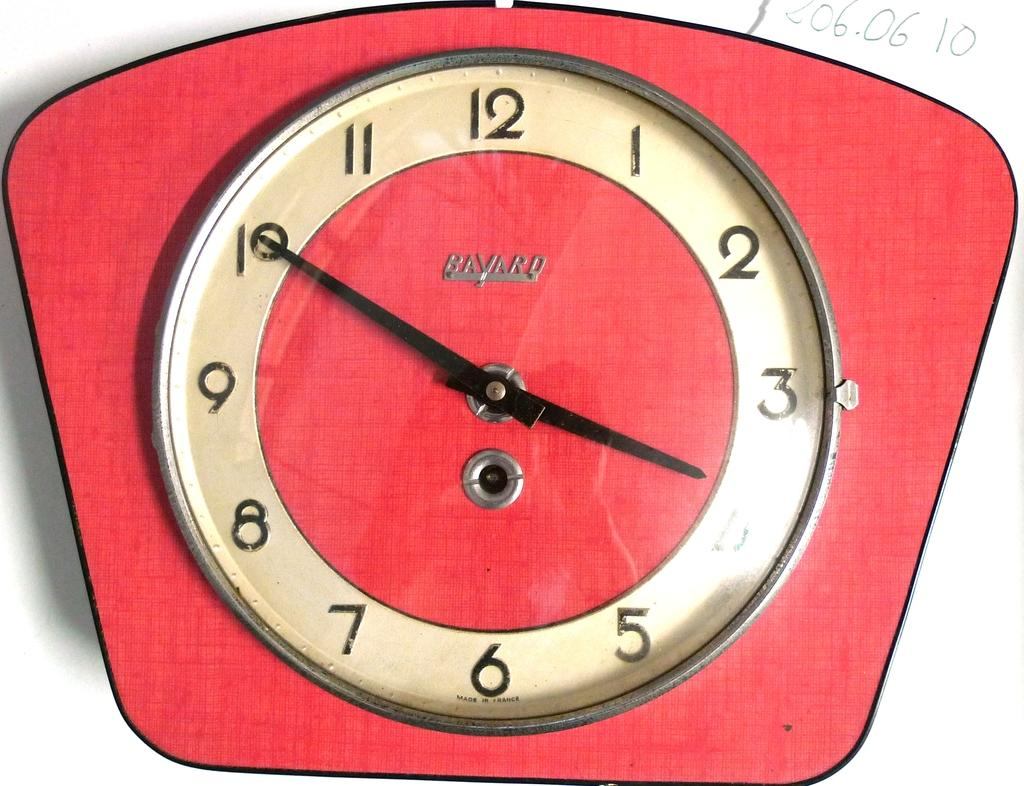<image>
Provide a brief description of the given image. A red clock has a Bayard logo on the face of it. 